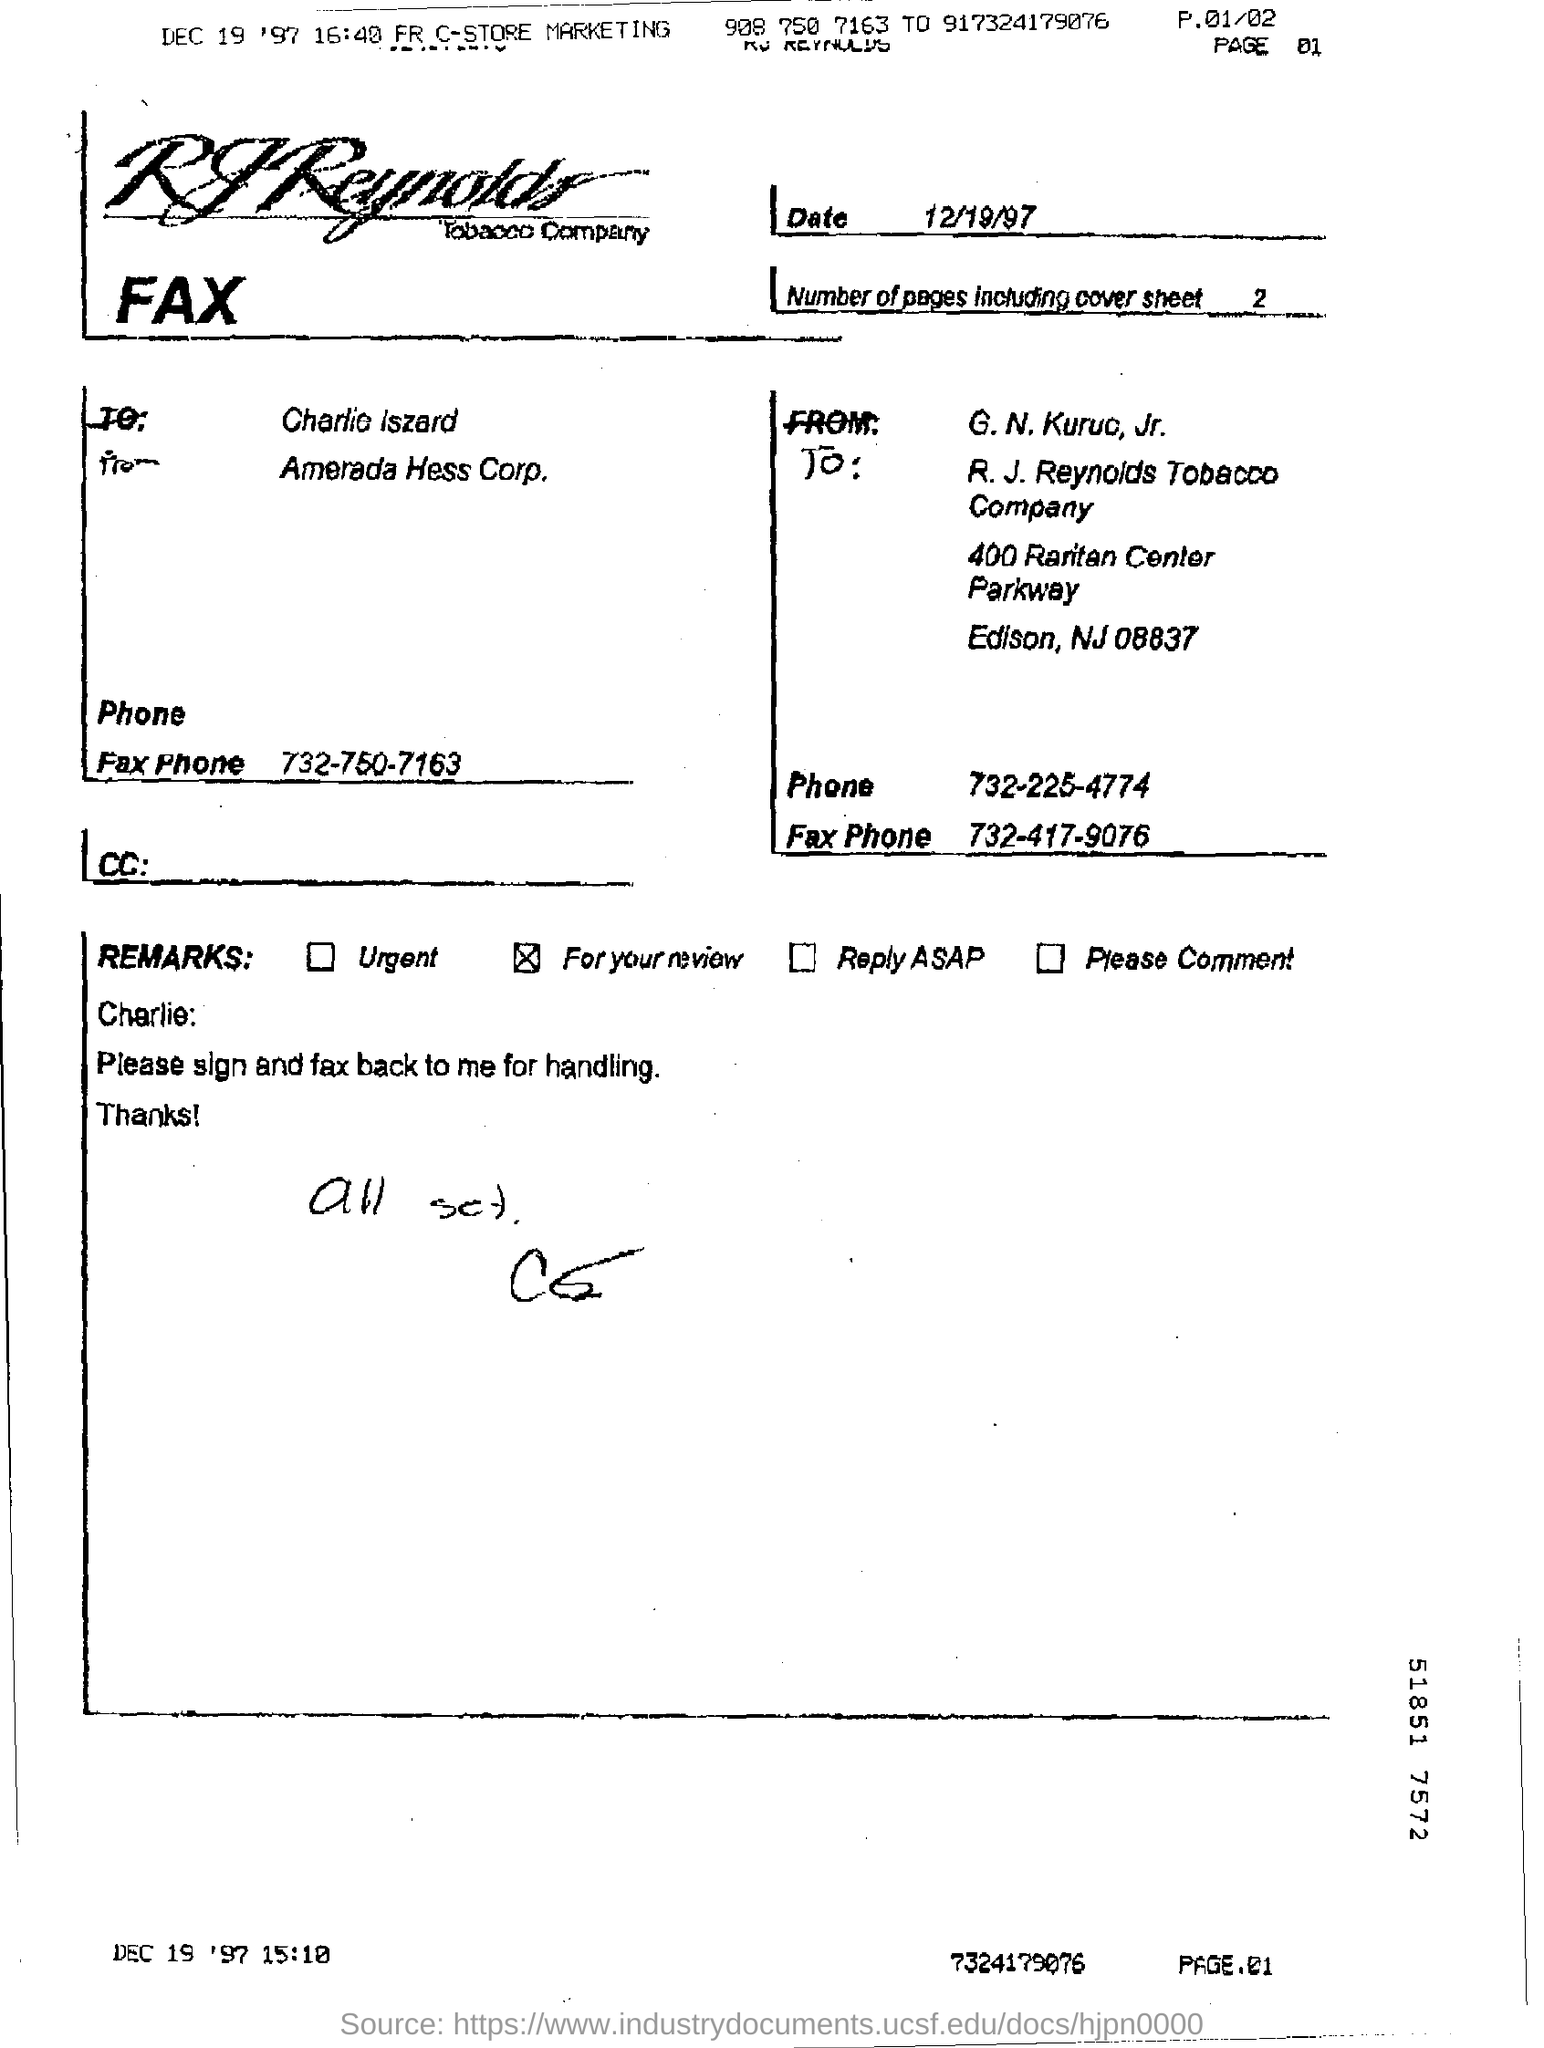Outline some significant characteristics in this image. The date on the fax is December 19, 1997. 